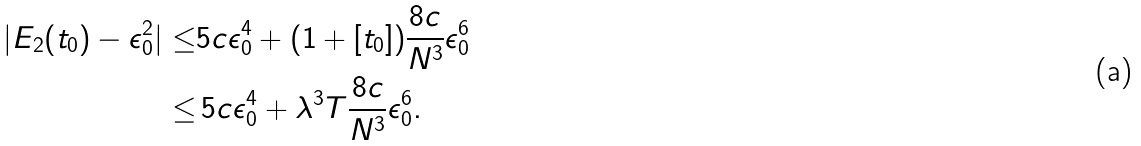Convert formula to latex. <formula><loc_0><loc_0><loc_500><loc_500>| E _ { 2 } ( t _ { 0 } ) - \epsilon _ { 0 } ^ { 2 } | \leq & 5 c \epsilon _ { 0 } ^ { 4 } + ( 1 + [ t _ { 0 } ] ) \frac { 8 c } { N ^ { 3 } } \epsilon _ { 0 } ^ { 6 } \\ \leq & \, 5 c \epsilon _ { 0 } ^ { 4 } + \lambda ^ { 3 } T \frac { 8 c } { N ^ { 3 } } \epsilon _ { 0 } ^ { 6 } .</formula> 